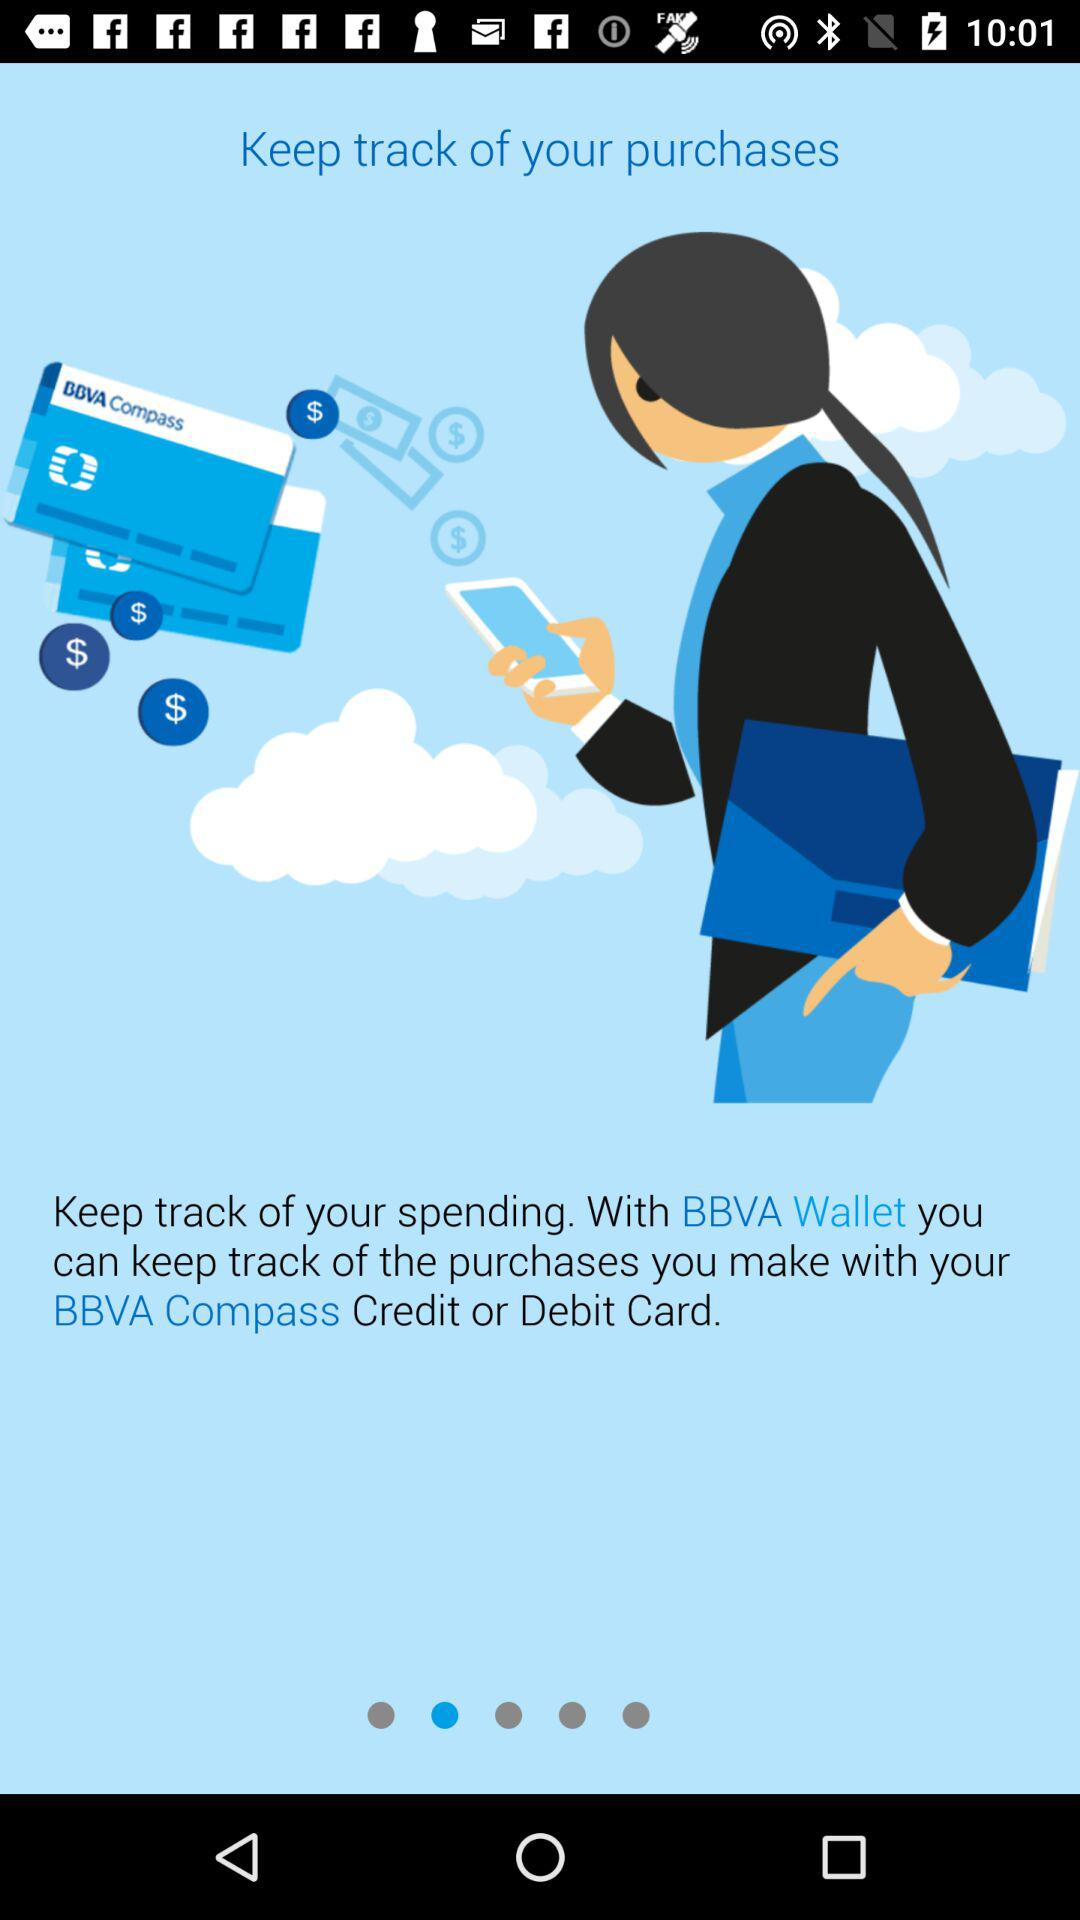Can I keep track on Purchase?
When the provided information is insufficient, respond with <no answer>. <no answer> 